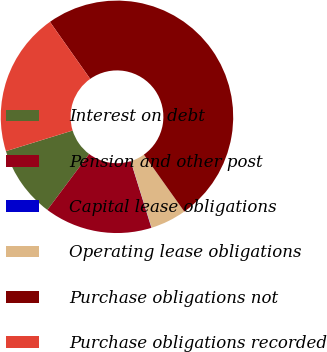Convert chart. <chart><loc_0><loc_0><loc_500><loc_500><pie_chart><fcel>Interest on debt<fcel>Pension and other post<fcel>Capital lease obligations<fcel>Operating lease obligations<fcel>Purchase obligations not<fcel>Purchase obligations recorded<nl><fcel>10.01%<fcel>15.0%<fcel>0.03%<fcel>5.02%<fcel>49.95%<fcel>19.99%<nl></chart> 